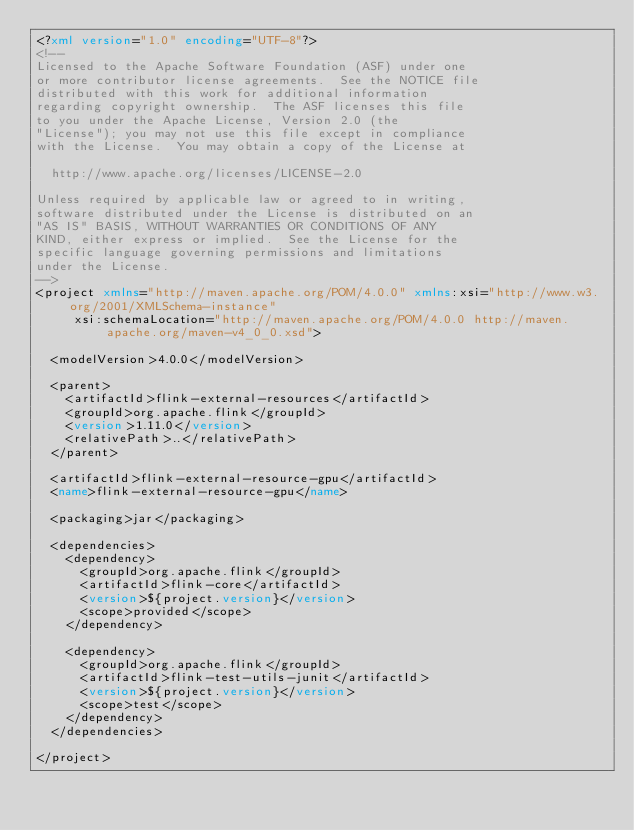Convert code to text. <code><loc_0><loc_0><loc_500><loc_500><_XML_><?xml version="1.0" encoding="UTF-8"?>
<!--
Licensed to the Apache Software Foundation (ASF) under one
or more contributor license agreements.  See the NOTICE file
distributed with this work for additional information
regarding copyright ownership.  The ASF licenses this file
to you under the Apache License, Version 2.0 (the
"License"); you may not use this file except in compliance
with the License.  You may obtain a copy of the License at

  http://www.apache.org/licenses/LICENSE-2.0

Unless required by applicable law or agreed to in writing,
software distributed under the License is distributed on an
"AS IS" BASIS, WITHOUT WARRANTIES OR CONDITIONS OF ANY
KIND, either express or implied.  See the License for the
specific language governing permissions and limitations
under the License.
-->
<project xmlns="http://maven.apache.org/POM/4.0.0" xmlns:xsi="http://www.w3.org/2001/XMLSchema-instance"
		 xsi:schemaLocation="http://maven.apache.org/POM/4.0.0 http://maven.apache.org/maven-v4_0_0.xsd">

	<modelVersion>4.0.0</modelVersion>

	<parent>
		<artifactId>flink-external-resources</artifactId>
		<groupId>org.apache.flink</groupId>
		<version>1.11.0</version>
		<relativePath>..</relativePath>
	</parent>

	<artifactId>flink-external-resource-gpu</artifactId>
	<name>flink-external-resource-gpu</name>

	<packaging>jar</packaging>

	<dependencies>
		<dependency>
			<groupId>org.apache.flink</groupId>
			<artifactId>flink-core</artifactId>
			<version>${project.version}</version>
			<scope>provided</scope>
		</dependency>

		<dependency>
			<groupId>org.apache.flink</groupId>
			<artifactId>flink-test-utils-junit</artifactId>
			<version>${project.version}</version>
			<scope>test</scope>
		</dependency>
	</dependencies>

</project>
</code> 